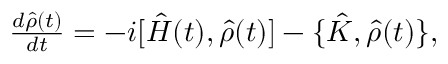<formula> <loc_0><loc_0><loc_500><loc_500>\begin{array} { r } { \frac { d \hat { \rho } ( t ) } { d t } = - i [ \hat { H } ( t ) , { \hat { \rho } ( t ) } ] - \{ \hat { K } , \hat { \rho } ( t ) \} , } \end{array}</formula> 